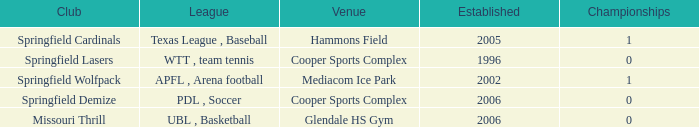What are the highest championships where the club is Springfield Cardinals? 1.0. 